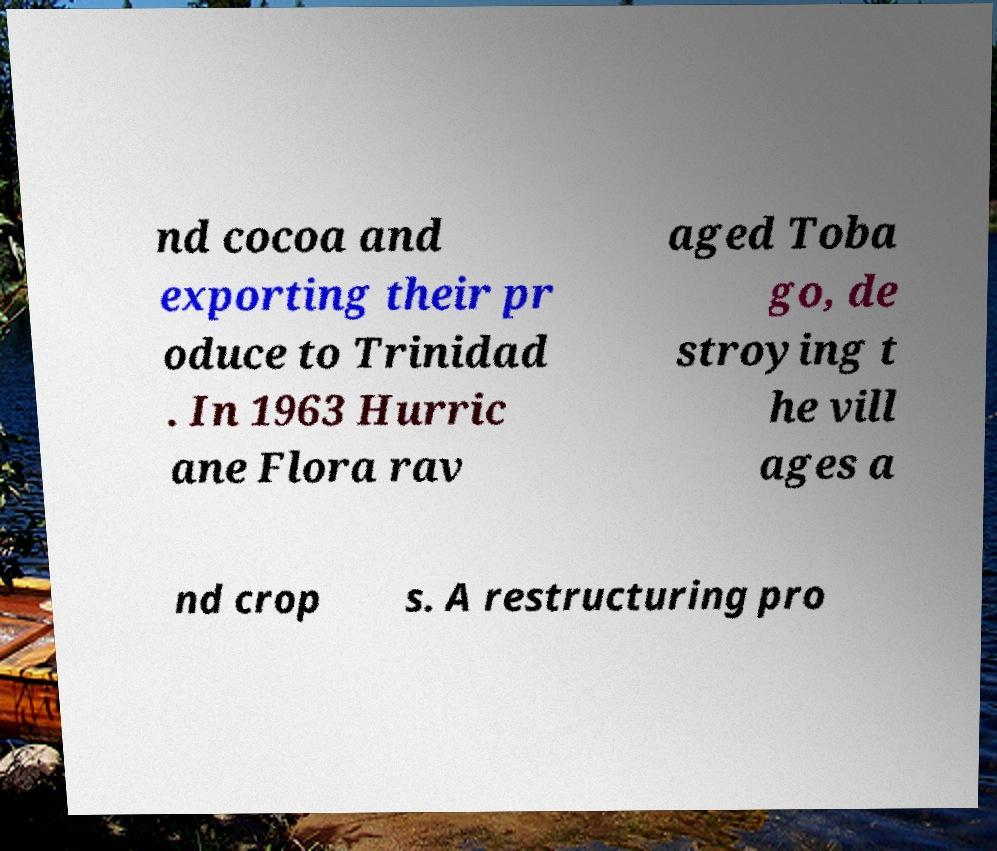Can you read and provide the text displayed in the image?This photo seems to have some interesting text. Can you extract and type it out for me? nd cocoa and exporting their pr oduce to Trinidad . In 1963 Hurric ane Flora rav aged Toba go, de stroying t he vill ages a nd crop s. A restructuring pro 